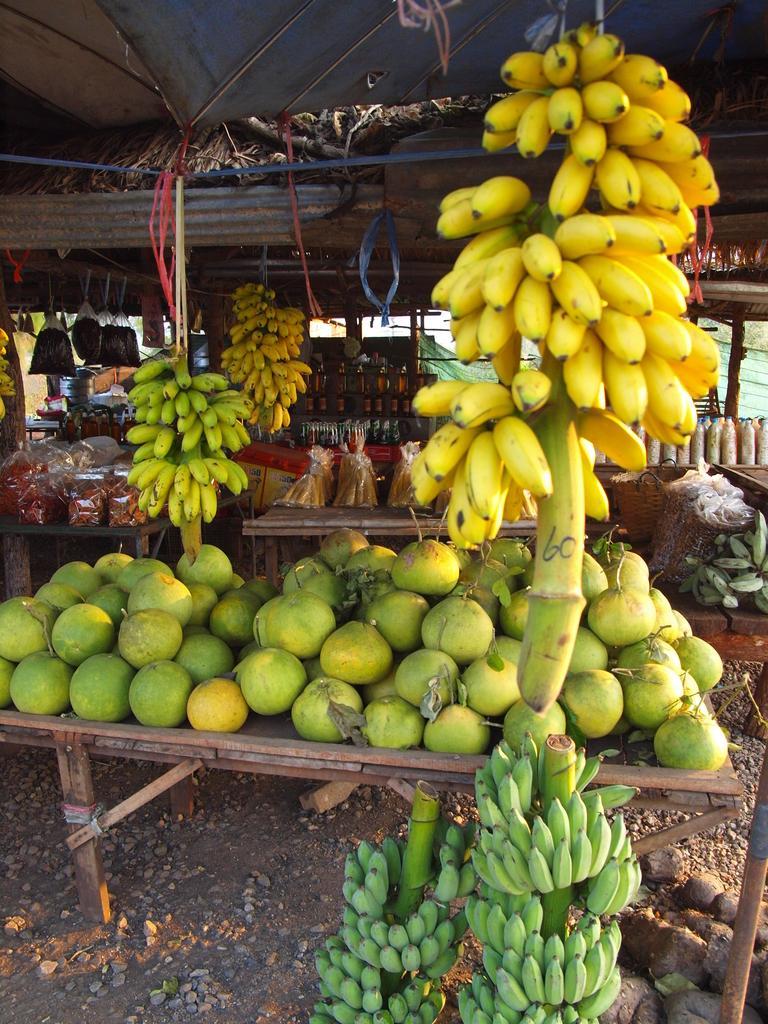How would you summarize this image in a sentence or two? In this image I can see the fruits which are in green and yellow color. I can see few fruits are on the table. To the side I can see few more items packed. These are in the shed. 